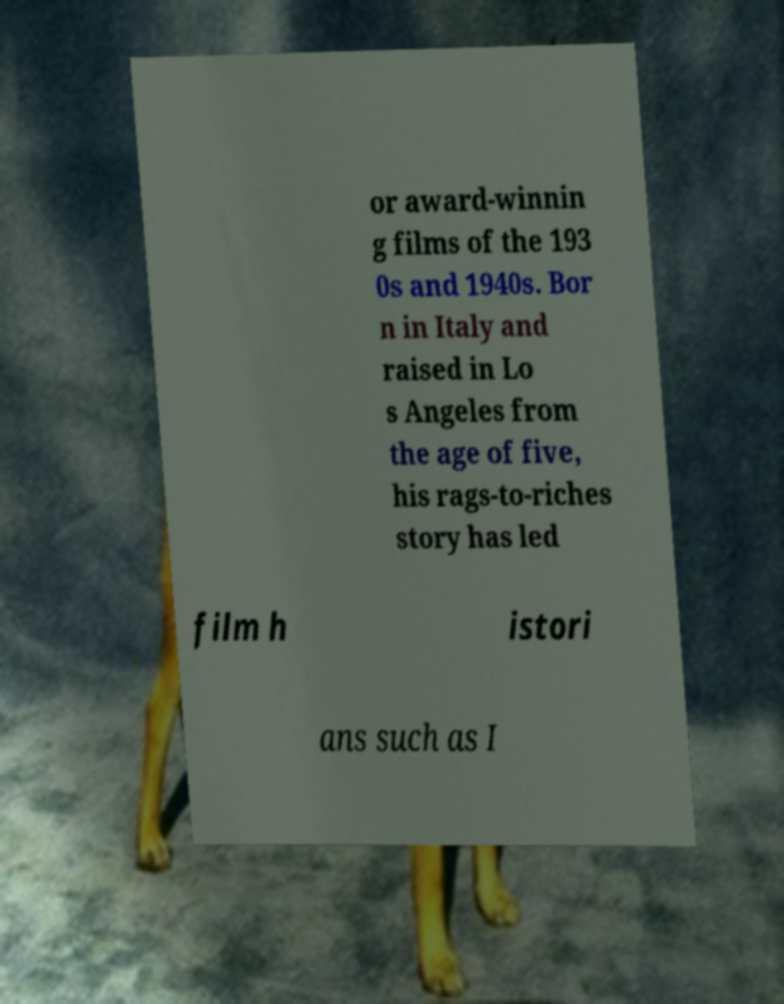Please identify and transcribe the text found in this image. or award-winnin g films of the 193 0s and 1940s. Bor n in Italy and raised in Lo s Angeles from the age of five, his rags-to-riches story has led film h istori ans such as I 